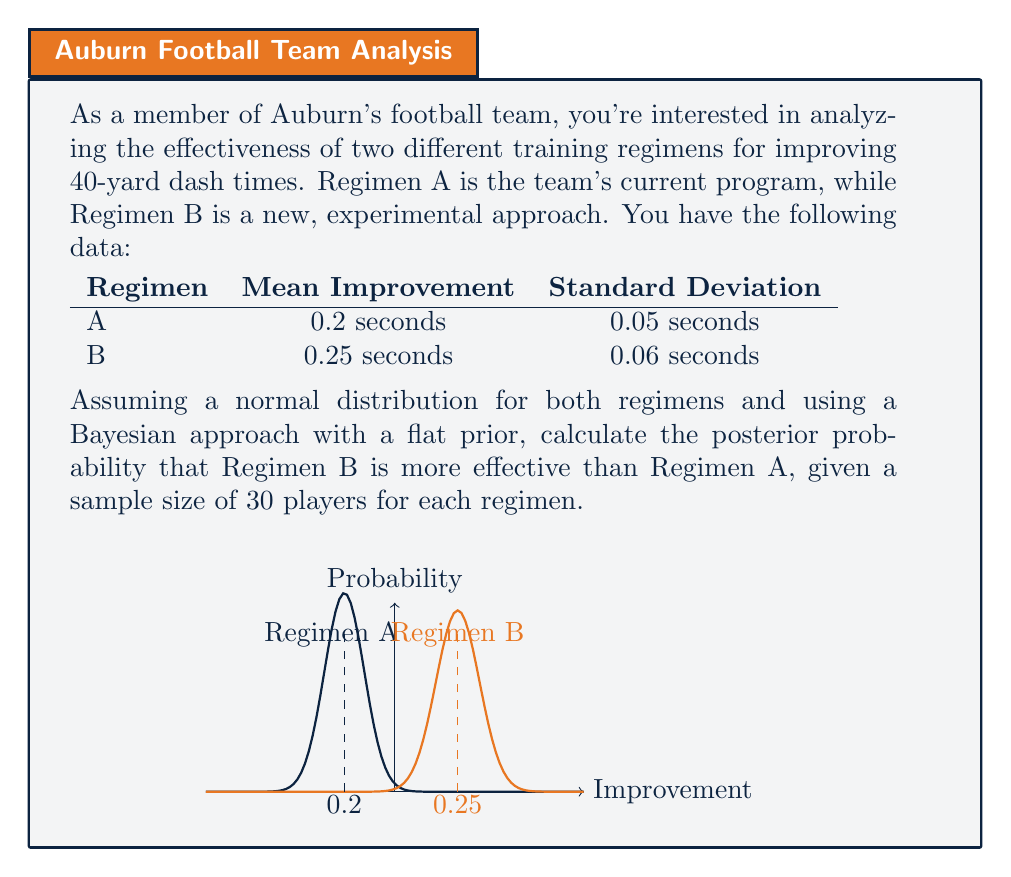What is the answer to this math problem? Let's approach this step-by-step using Bayesian hypothesis testing:

1) First, we need to calculate the standard error (SE) for the difference in means:

   $SE = \sqrt{\frac{\sigma_A^2}{n_A} + \frac{\sigma_B^2}{n_B}}$

   Where $\sigma_A$ and $\sigma_B$ are the standard deviations, and $n_A$ and $n_B$ are the sample sizes.

   $SE = \sqrt{\frac{0.05^2}{30} + \frac{0.06^2}{30}} = \sqrt{0.0000833 + 0.00012} = 0.0152$

2) Now, we calculate the z-score for the difference in means:

   $z = \frac{\bar{x}_B - \bar{x}_A}{SE} = \frac{0.25 - 0.2}{0.0152} = 3.29$

3) In Bayesian hypothesis testing with a flat prior, the posterior probability that Regimen B is more effective than Regimen A is equivalent to the area under the standard normal curve to the right of -z.

4) We can calculate this using the standard normal cumulative distribution function (Φ):

   $P(B > A) = Φ(z) = Φ(3.29)$

5) Using a standard normal table or calculator, we find:

   $Φ(3.29) ≈ 0.9995$

Therefore, the posterior probability that Regimen B is more effective than Regimen A is approximately 0.9995 or 99.95%.
Answer: 0.9995 